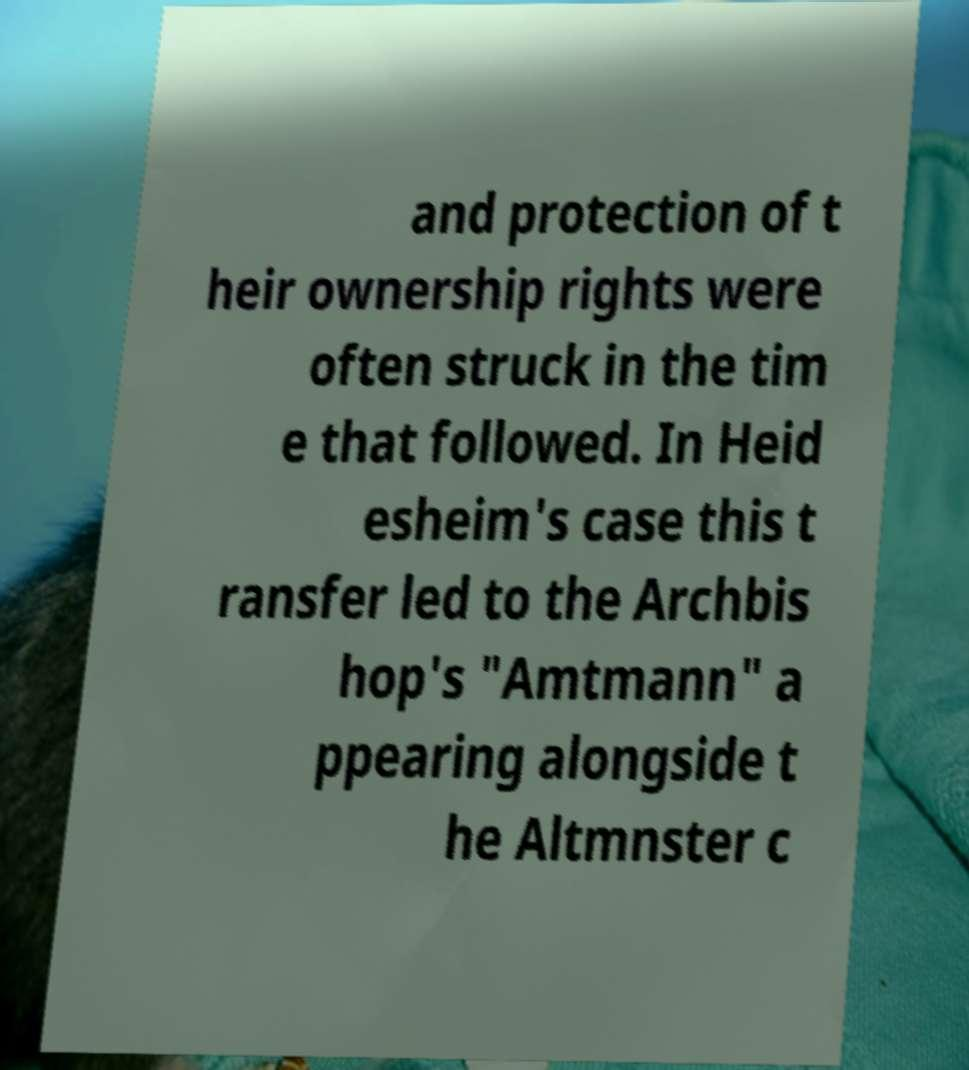Could you extract and type out the text from this image? and protection of t heir ownership rights were often struck in the tim e that followed. In Heid esheim's case this t ransfer led to the Archbis hop's "Amtmann" a ppearing alongside t he Altmnster c 